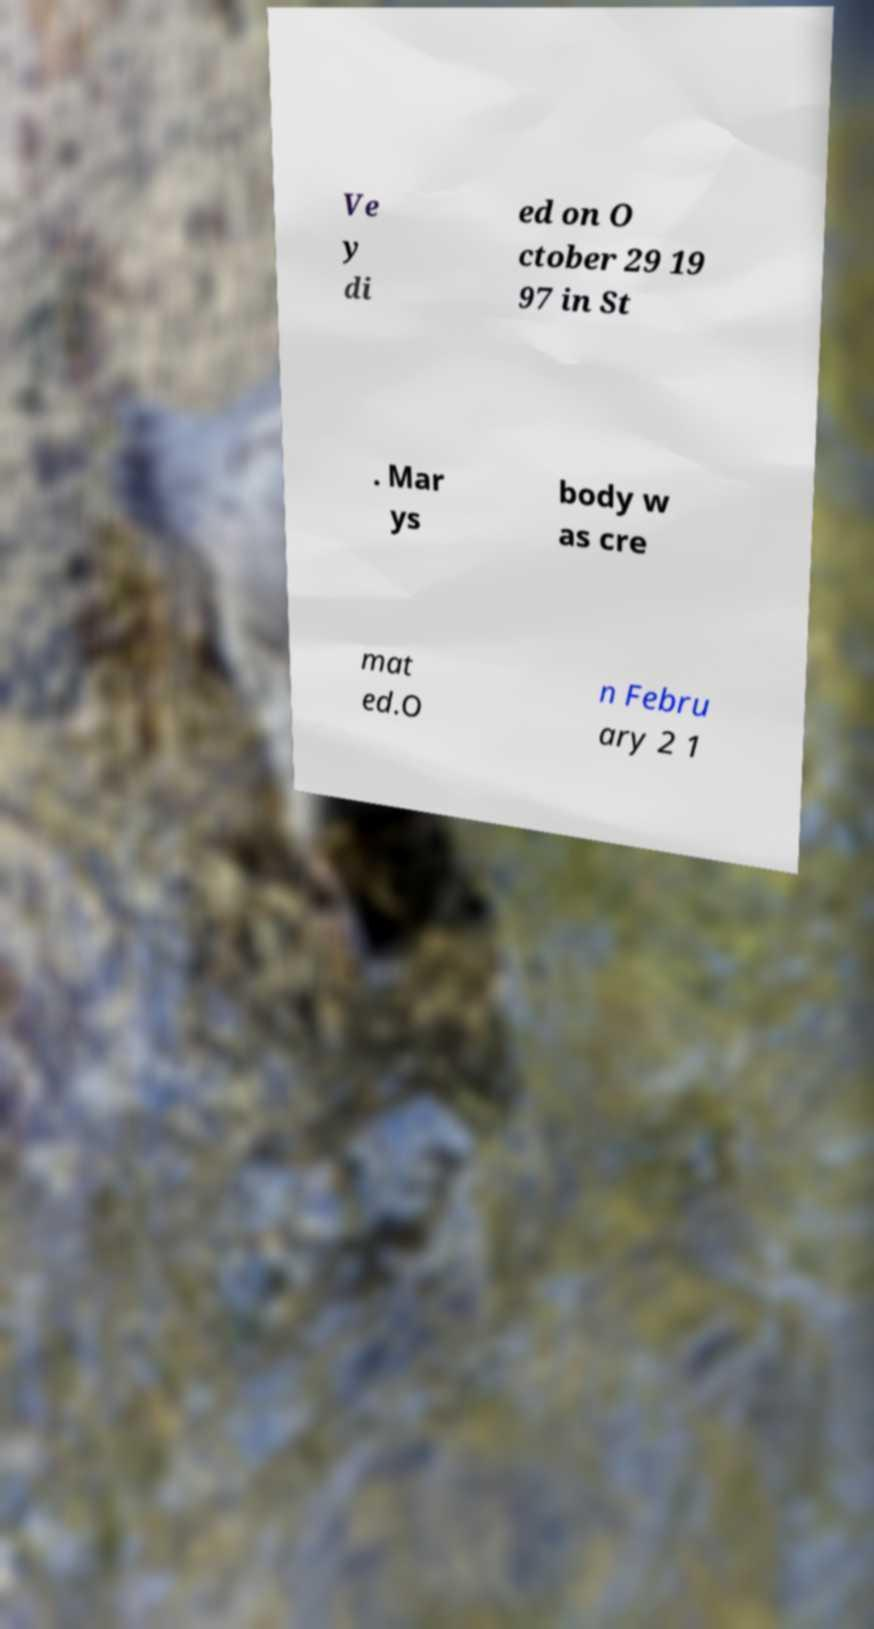Please read and relay the text visible in this image. What does it say? Ve y di ed on O ctober 29 19 97 in St . Mar ys body w as cre mat ed.O n Febru ary 2 1 